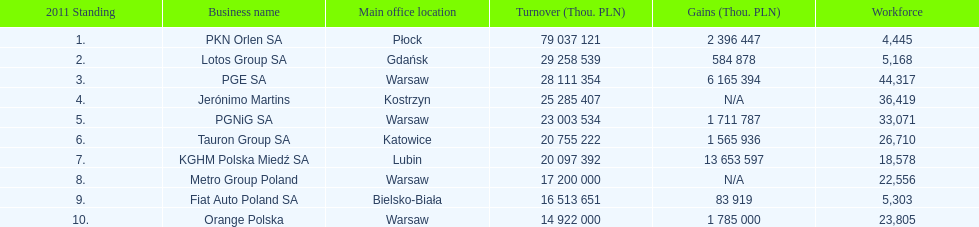Which company had the most revenue? PKN Orlen SA. 